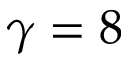Convert formula to latex. <formula><loc_0><loc_0><loc_500><loc_500>\gamma = 8</formula> 